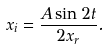Convert formula to latex. <formula><loc_0><loc_0><loc_500><loc_500>x _ { i } = \frac { A \sin 2 t } { 2 x _ { r } } .</formula> 